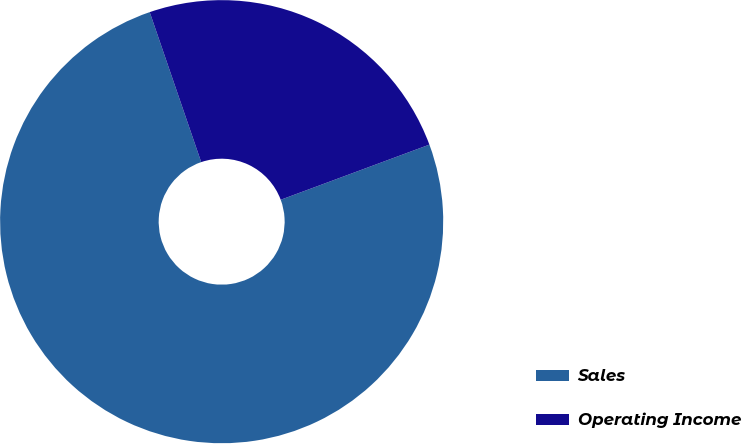<chart> <loc_0><loc_0><loc_500><loc_500><pie_chart><fcel>Sales<fcel>Operating Income<nl><fcel>75.39%<fcel>24.61%<nl></chart> 